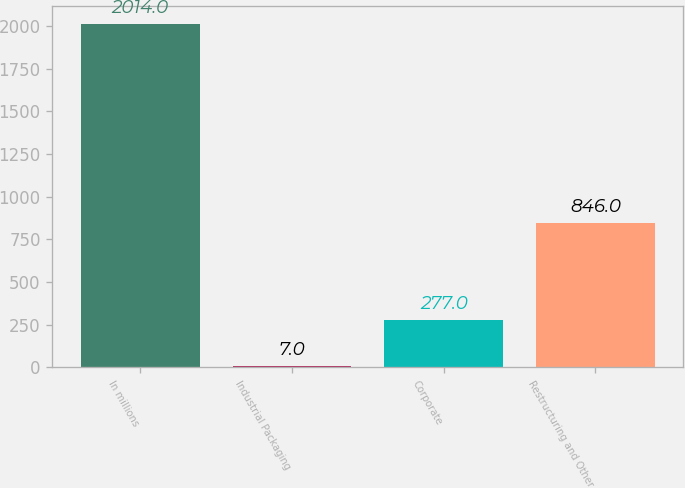<chart> <loc_0><loc_0><loc_500><loc_500><bar_chart><fcel>In millions<fcel>Industrial Packaging<fcel>Corporate<fcel>Restructuring and Other<nl><fcel>2014<fcel>7<fcel>277<fcel>846<nl></chart> 